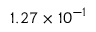<formula> <loc_0><loc_0><loc_500><loc_500>1 . 2 7 \times 1 0 ^ { - 1 }</formula> 